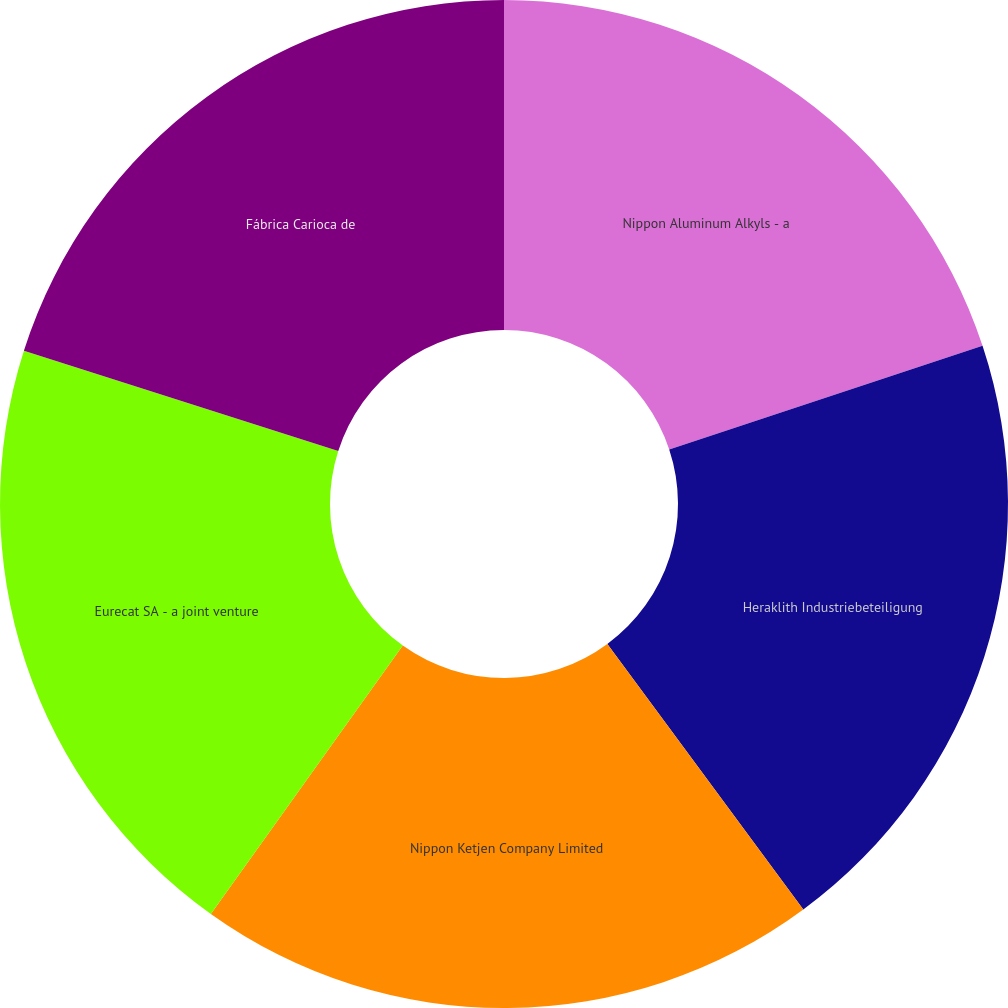<chart> <loc_0><loc_0><loc_500><loc_500><pie_chart><fcel>Nippon Aluminum Alkyls - a<fcel>Heraklith Industriebeteiligung<fcel>Nippon Ketjen Company Limited<fcel>Eurecat SA - a joint venture<fcel>Fábrica Carioca de<nl><fcel>19.92%<fcel>19.96%<fcel>20.0%<fcel>20.04%<fcel>20.08%<nl></chart> 